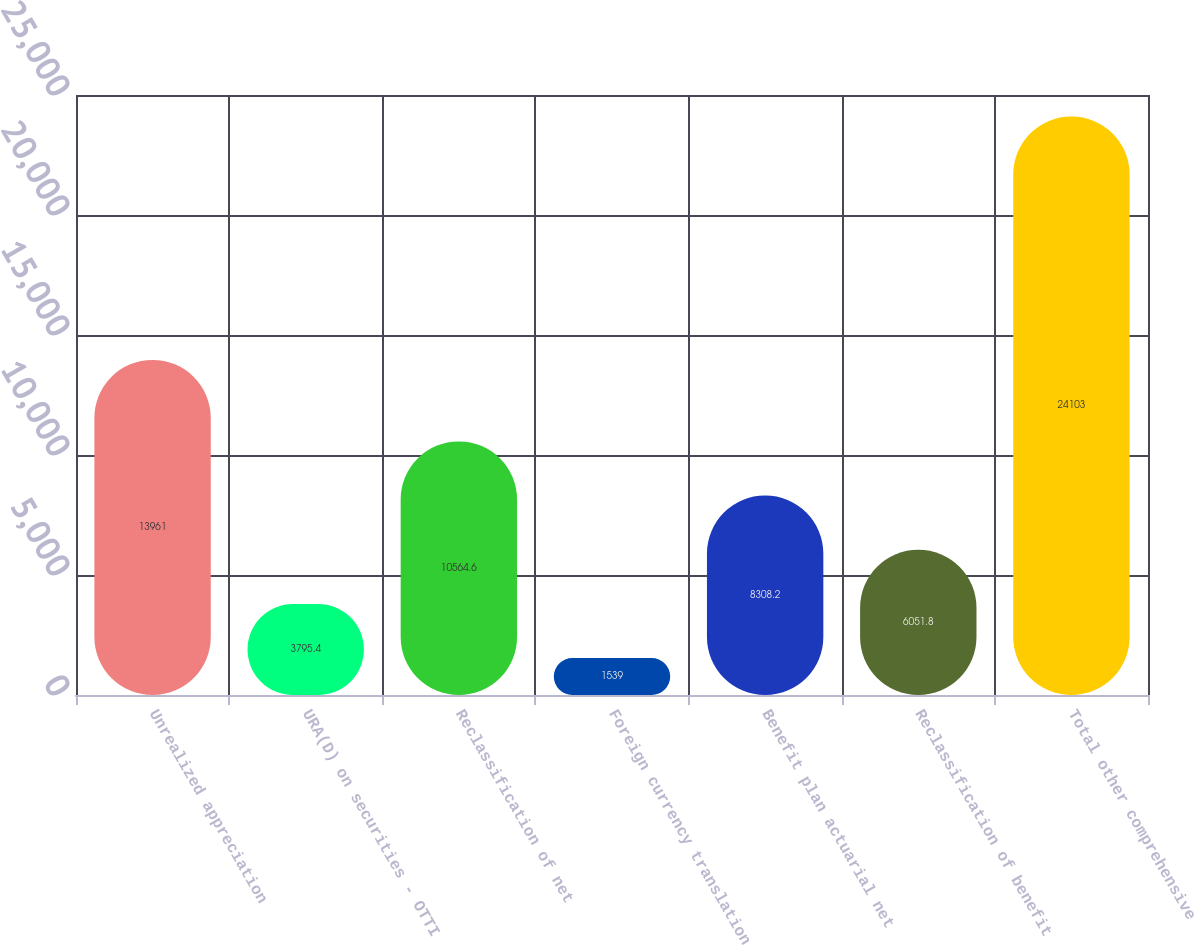Convert chart. <chart><loc_0><loc_0><loc_500><loc_500><bar_chart><fcel>Unrealized appreciation<fcel>URA(D) on securities - OTTI<fcel>Reclassification of net<fcel>Foreign currency translation<fcel>Benefit plan actuarial net<fcel>Reclassification of benefit<fcel>Total other comprehensive<nl><fcel>13961<fcel>3795.4<fcel>10564.6<fcel>1539<fcel>8308.2<fcel>6051.8<fcel>24103<nl></chart> 